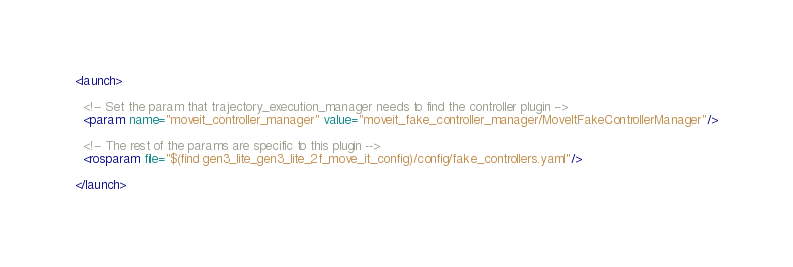<code> <loc_0><loc_0><loc_500><loc_500><_XML_><launch>

  <!-- Set the param that trajectory_execution_manager needs to find the controller plugin -->
  <param name="moveit_controller_manager" value="moveit_fake_controller_manager/MoveItFakeControllerManager"/>

  <!-- The rest of the params are specific to this plugin -->
  <rosparam file="$(find gen3_lite_gen3_lite_2f_move_it_config)/config/fake_controllers.yaml"/>

</launch>
</code> 